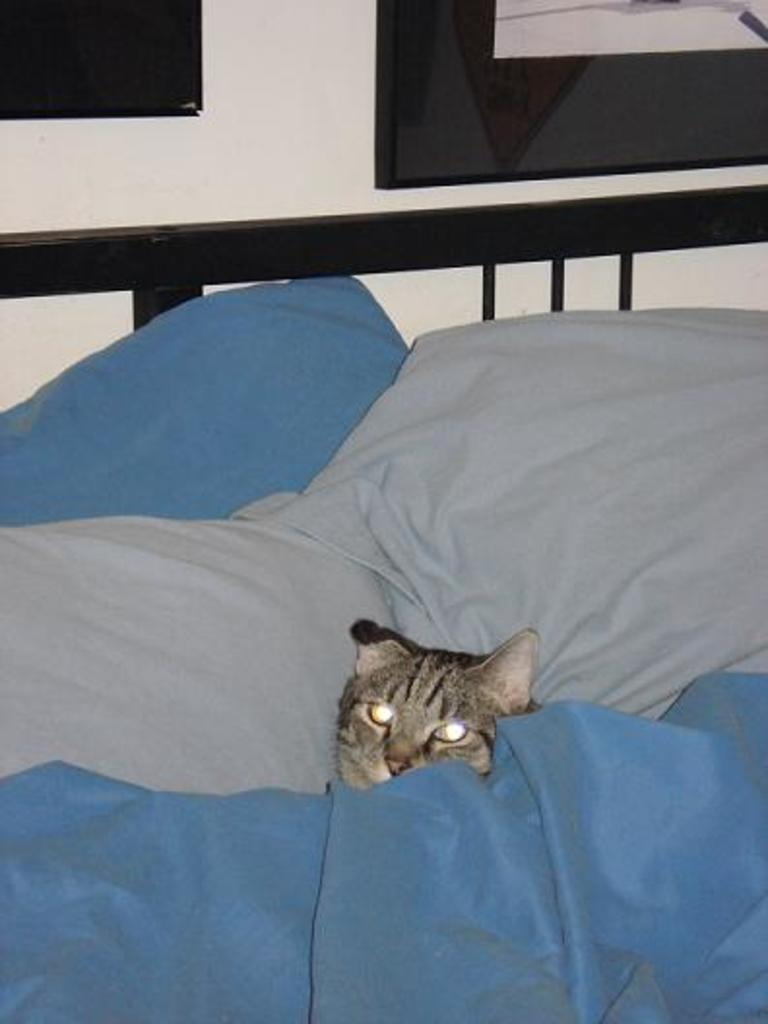What animal can be seen lying on the bed in the image? There is a cat lying on the bed in the image. What else is present in the image besides the cat? There are clothes in the image. What can be seen on the wall in the background of the image? There are black colored objects attached to the wall in the background. What type of arch can be seen in the image? There is no arch present in the image. What is the cat writing on the bed in the image? The cat is not writing anything in the image, as cats do not have the ability to write. 